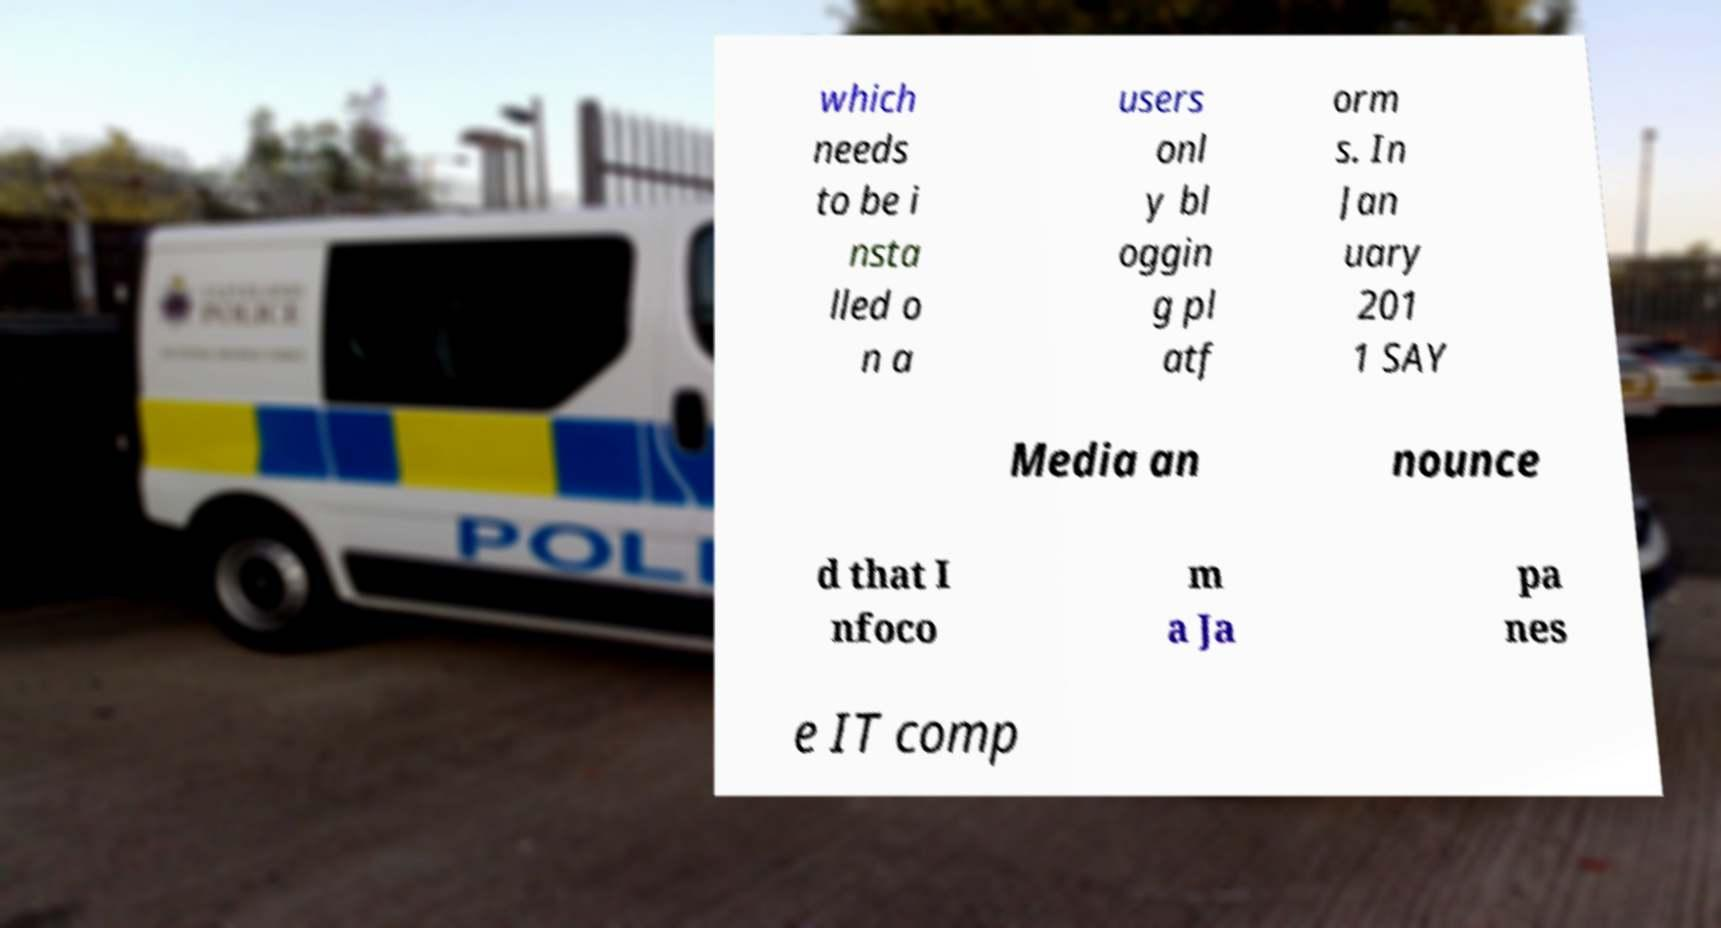Could you assist in decoding the text presented in this image and type it out clearly? which needs to be i nsta lled o n a users onl y bl oggin g pl atf orm s. In Jan uary 201 1 SAY Media an nounce d that I nfoco m a Ja pa nes e IT comp 